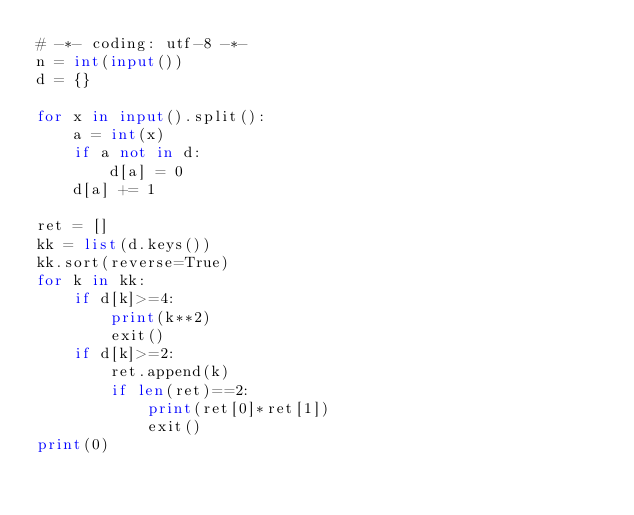<code> <loc_0><loc_0><loc_500><loc_500><_Python_># -*- coding: utf-8 -*-
n = int(input())
d = {}

for x in input().split():
    a = int(x)
    if a not in d:
        d[a] = 0
    d[a] += 1

ret = []
kk = list(d.keys())
kk.sort(reverse=True)
for k in kk:
    if d[k]>=4:
        print(k**2)
        exit()
    if d[k]>=2:
        ret.append(k)
        if len(ret)==2:
            print(ret[0]*ret[1])
            exit()
print(0)
</code> 